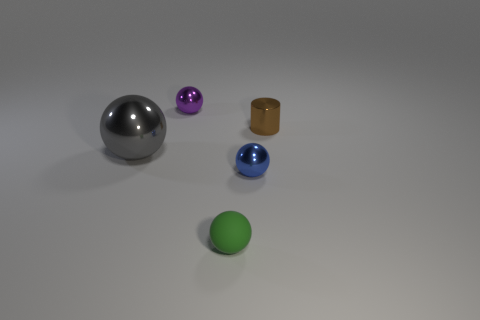What is the size of the brown object that is behind the small blue shiny object?
Offer a terse response. Small. How many cyan objects are rubber things or metal balls?
Offer a very short reply. 0. Is there anything else that has the same material as the green object?
Provide a succinct answer. No. What material is the other blue thing that is the same shape as the matte object?
Make the answer very short. Metal. Are there the same number of small metal spheres behind the large gray object and small metal balls?
Keep it short and to the point. No. What is the size of the metallic object that is in front of the brown cylinder and right of the green ball?
Your answer should be compact. Small. Is there anything else that has the same color as the cylinder?
Make the answer very short. No. What size is the object to the left of the tiny shiny sphere that is behind the small cylinder?
Give a very brief answer. Large. What is the color of the sphere that is both behind the blue metal object and in front of the small brown metal cylinder?
Your answer should be compact. Gray. How many other things are the same size as the gray thing?
Your response must be concise. 0. 